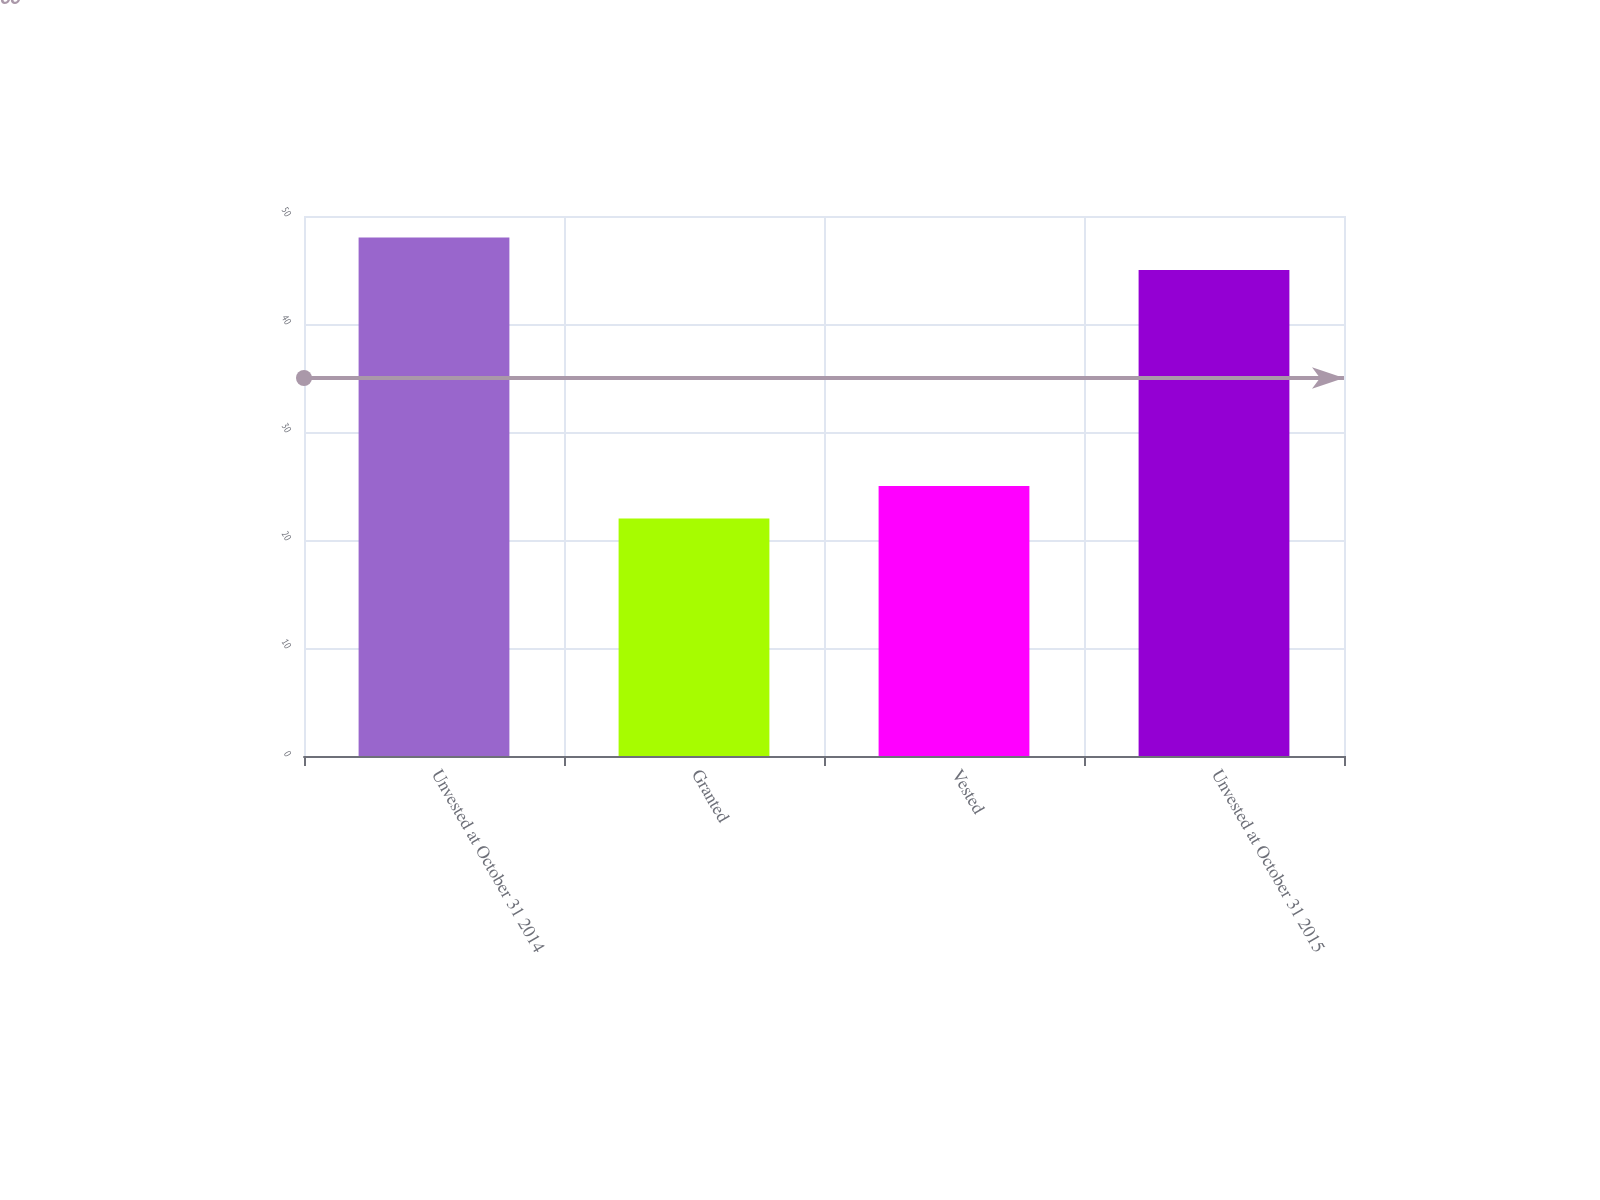<chart> <loc_0><loc_0><loc_500><loc_500><bar_chart><fcel>Unvested at October 31 2014<fcel>Granted<fcel>Vested<fcel>Unvested at October 31 2015<nl><fcel>48<fcel>22<fcel>25<fcel>45<nl></chart> 